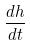Convert formula to latex. <formula><loc_0><loc_0><loc_500><loc_500>\frac { d h } { d t }</formula> 